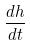Convert formula to latex. <formula><loc_0><loc_0><loc_500><loc_500>\frac { d h } { d t }</formula> 